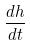Convert formula to latex. <formula><loc_0><loc_0><loc_500><loc_500>\frac { d h } { d t }</formula> 